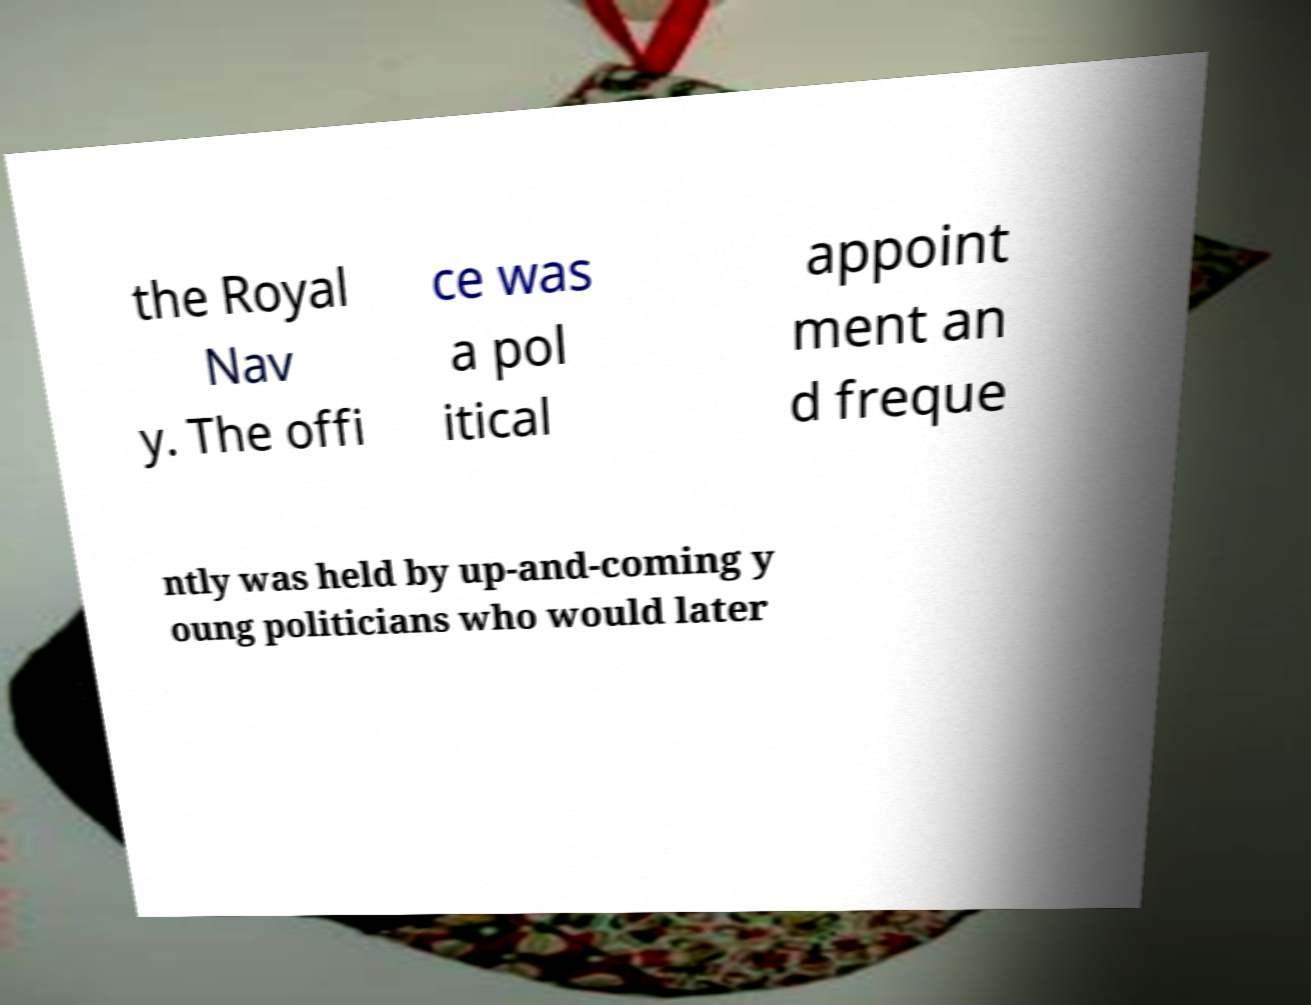Please read and relay the text visible in this image. What does it say? the Royal Nav y. The offi ce was a pol itical appoint ment an d freque ntly was held by up-and-coming y oung politicians who would later 